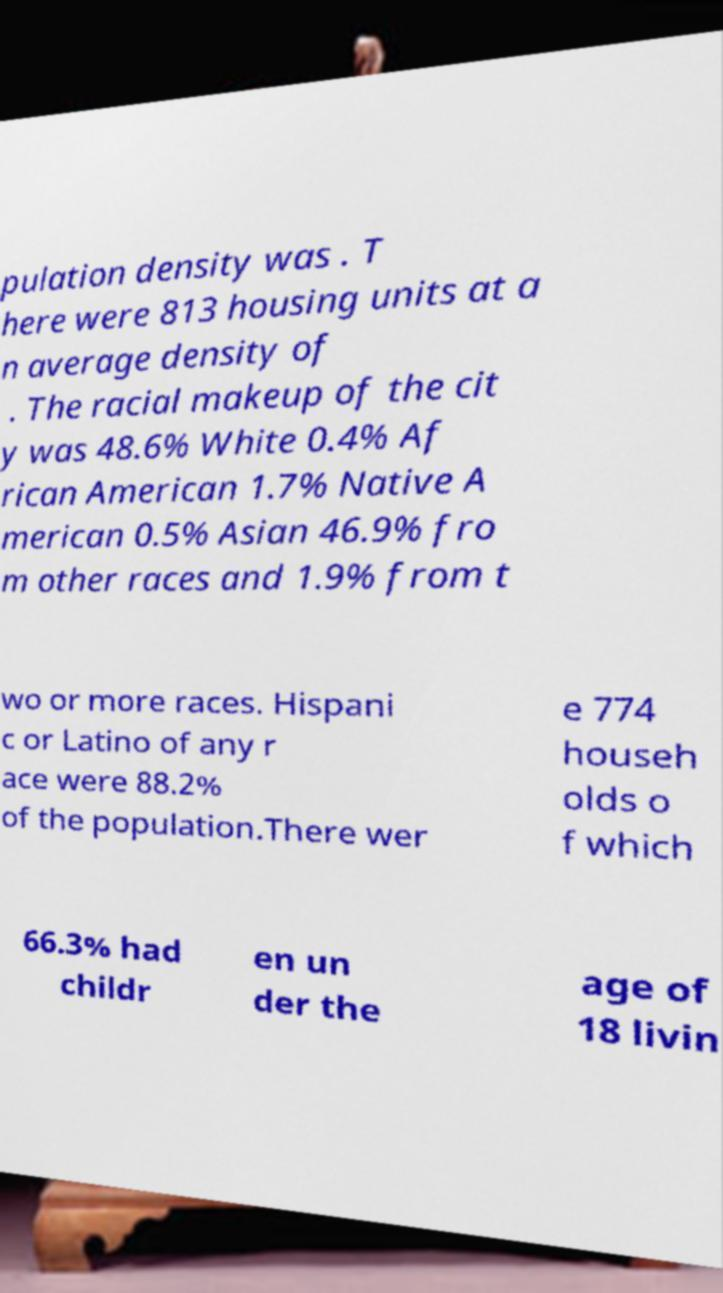Can you accurately transcribe the text from the provided image for me? pulation density was . T here were 813 housing units at a n average density of . The racial makeup of the cit y was 48.6% White 0.4% Af rican American 1.7% Native A merican 0.5% Asian 46.9% fro m other races and 1.9% from t wo or more races. Hispani c or Latino of any r ace were 88.2% of the population.There wer e 774 househ olds o f which 66.3% had childr en un der the age of 18 livin 